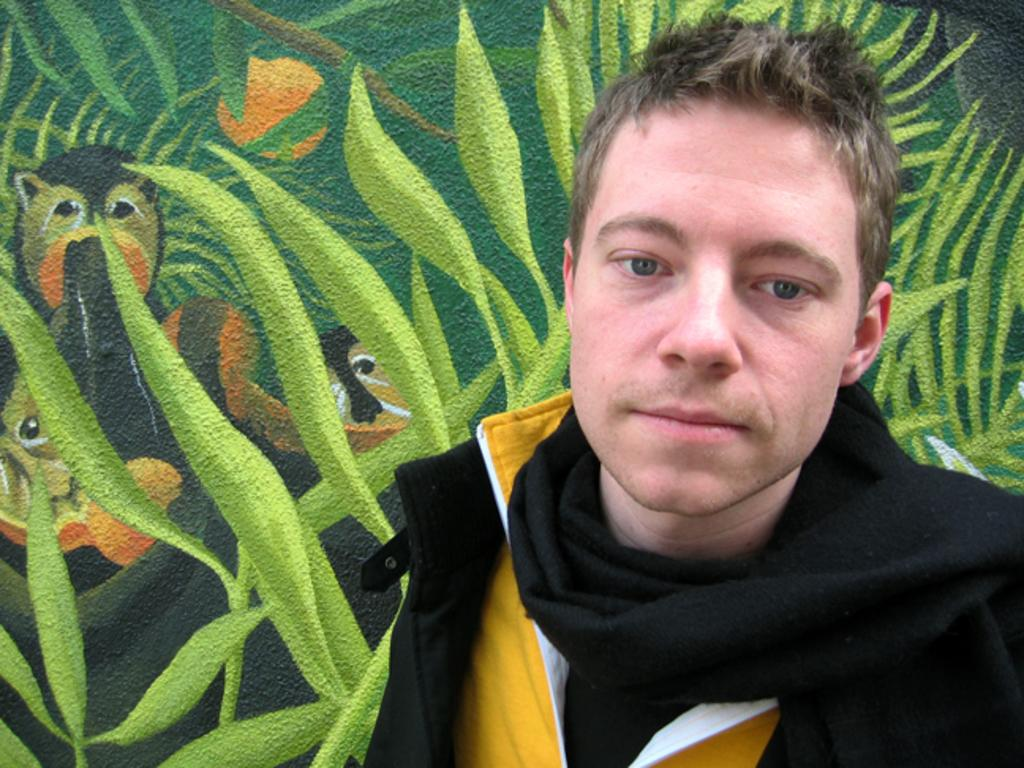What is the main subject of the picture? The main subject of the picture is a man standing. What is the man wearing in the picture? The man is wearing a black color scarf and a black color coat. What can be seen on the wall in the picture? There is a painting of leaves and animals on the wall. What type of coil is being used to hold the leaves in the painting? There is no coil present in the painting; it features leaves and animals without any visible coil. What is the monetary value of the painting in the image? The facts provided do not give any information about the painting's value, so it cannot be determined from the image. 